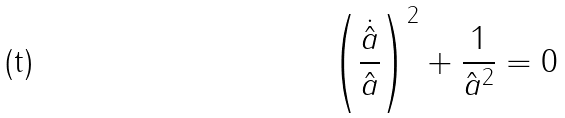Convert formula to latex. <formula><loc_0><loc_0><loc_500><loc_500>\left ( \frac { \dot { \hat { a } } } { \hat { a } } \right ) ^ { 2 } + \frac { 1 } { \hat { a } ^ { 2 } } = 0</formula> 